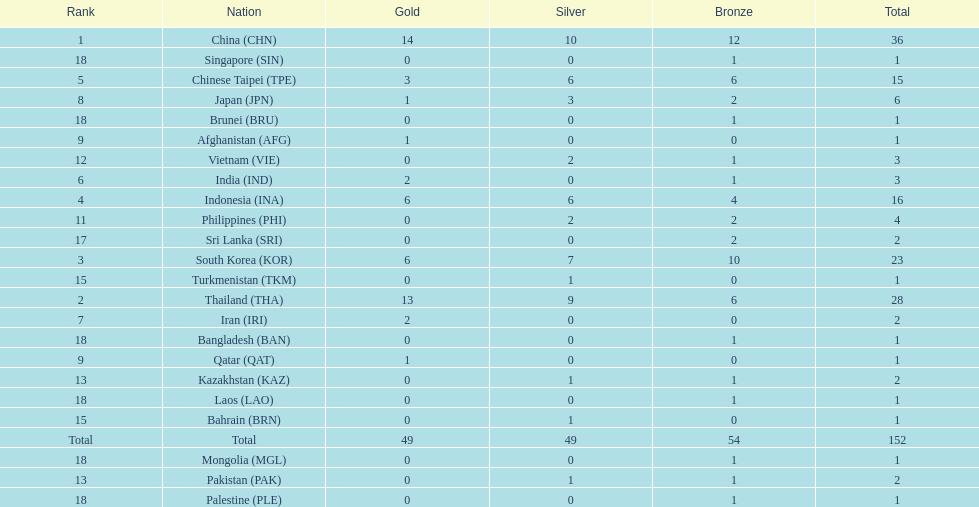Did the philippines or kazakhstan have a higher number of total medals? Philippines. 